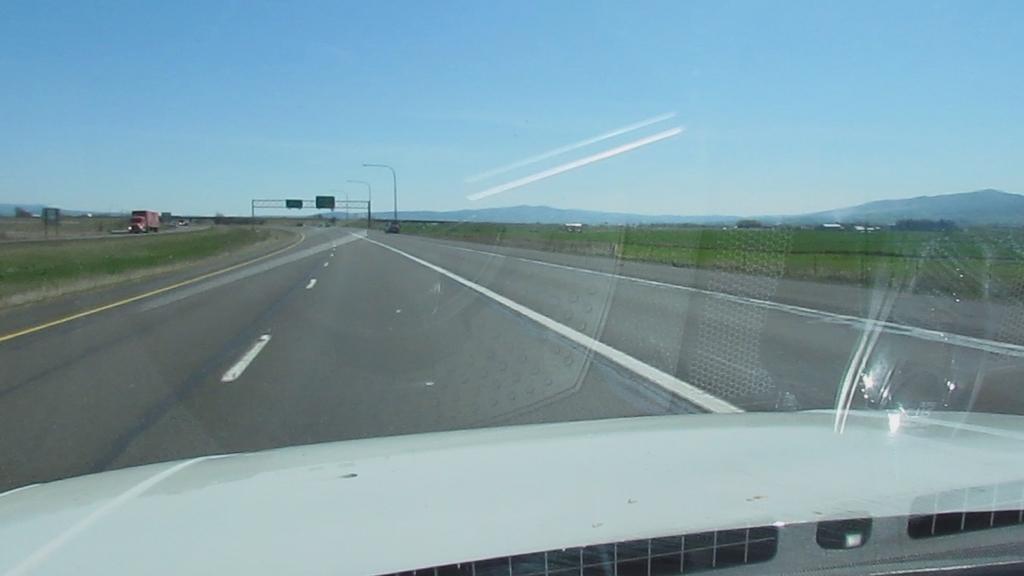Please provide a concise description of this image. This picture is taken in a highway on either side of the road there is grass land, in left side there is vehicle moving in the background there are poles, mountains and sky. 